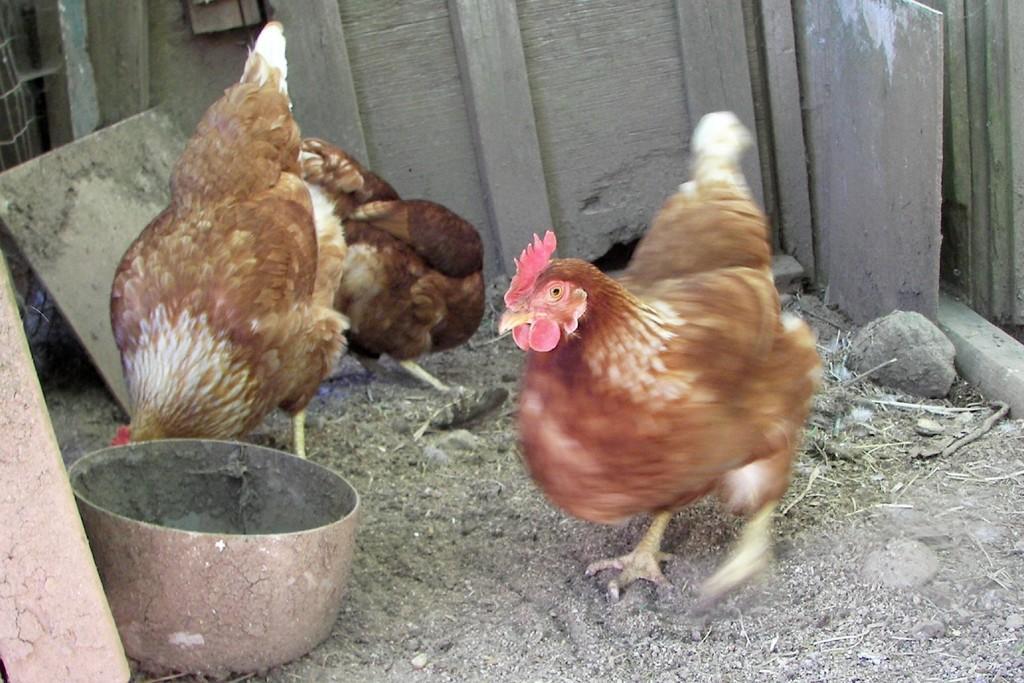Could you give a brief overview of what you see in this image? This image consists of three hens. At the bottom, there is ground. In the background, we can see the wooden pieces and a rock. On the left, it looks like a bowl. 